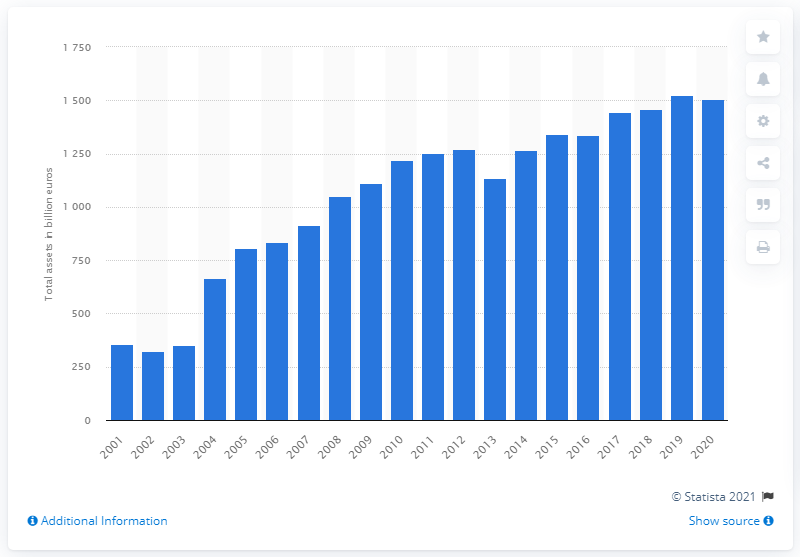Outline some significant characteristics in this image. Banco Santander's total assets in 2020 were 1508.3 billion. In 2001, Banco Santander's total assets were 358.1... 